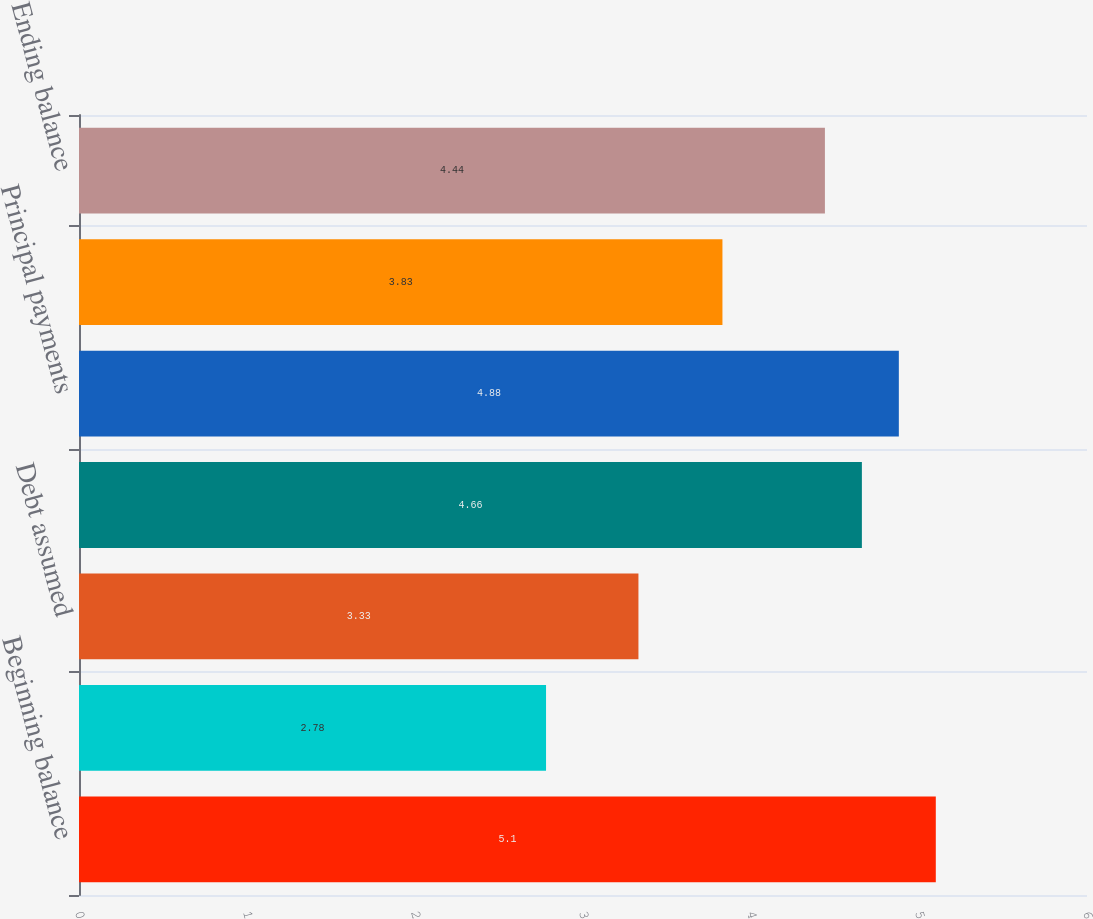Convert chart to OTSL. <chart><loc_0><loc_0><loc_500><loc_500><bar_chart><fcel>Beginning balance<fcel>Debt issued<fcel>Debt assumed<fcel>Debt extinguished<fcel>Principal payments<fcel>Foreign currency<fcel>Ending balance<nl><fcel>5.1<fcel>2.78<fcel>3.33<fcel>4.66<fcel>4.88<fcel>3.83<fcel>4.44<nl></chart> 